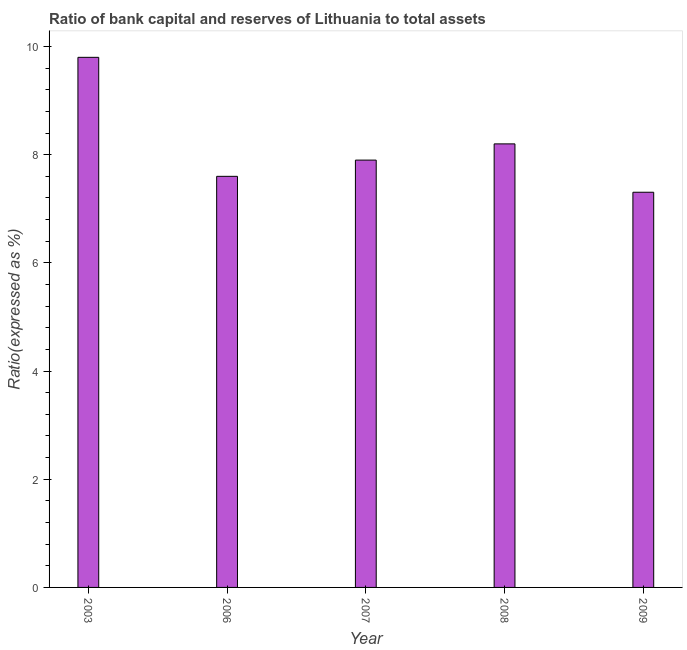What is the title of the graph?
Your answer should be compact. Ratio of bank capital and reserves of Lithuania to total assets. What is the label or title of the X-axis?
Your response must be concise. Year. What is the label or title of the Y-axis?
Your answer should be very brief. Ratio(expressed as %). What is the bank capital to assets ratio in 2008?
Make the answer very short. 8.2. Across all years, what is the maximum bank capital to assets ratio?
Make the answer very short. 9.8. Across all years, what is the minimum bank capital to assets ratio?
Offer a terse response. 7.31. In which year was the bank capital to assets ratio minimum?
Offer a terse response. 2009. What is the sum of the bank capital to assets ratio?
Give a very brief answer. 40.81. What is the average bank capital to assets ratio per year?
Your answer should be compact. 8.16. What is the median bank capital to assets ratio?
Your response must be concise. 7.9. In how many years, is the bank capital to assets ratio greater than 8.8 %?
Ensure brevity in your answer.  1. What is the ratio of the bank capital to assets ratio in 2003 to that in 2008?
Provide a succinct answer. 1.2. Is the bank capital to assets ratio in 2007 less than that in 2008?
Ensure brevity in your answer.  Yes. Is the difference between the bank capital to assets ratio in 2007 and 2008 greater than the difference between any two years?
Keep it short and to the point. No. What is the difference between the highest and the lowest bank capital to assets ratio?
Your answer should be very brief. 2.49. How many bars are there?
Provide a short and direct response. 5. Are all the bars in the graph horizontal?
Offer a very short reply. No. Are the values on the major ticks of Y-axis written in scientific E-notation?
Provide a succinct answer. No. What is the Ratio(expressed as %) of 2009?
Make the answer very short. 7.31. What is the difference between the Ratio(expressed as %) in 2003 and 2006?
Your answer should be very brief. 2.2. What is the difference between the Ratio(expressed as %) in 2003 and 2009?
Keep it short and to the point. 2.49. What is the difference between the Ratio(expressed as %) in 2006 and 2007?
Ensure brevity in your answer.  -0.3. What is the difference between the Ratio(expressed as %) in 2006 and 2009?
Make the answer very short. 0.29. What is the difference between the Ratio(expressed as %) in 2007 and 2008?
Give a very brief answer. -0.3. What is the difference between the Ratio(expressed as %) in 2007 and 2009?
Make the answer very short. 0.59. What is the difference between the Ratio(expressed as %) in 2008 and 2009?
Ensure brevity in your answer.  0.89. What is the ratio of the Ratio(expressed as %) in 2003 to that in 2006?
Your answer should be compact. 1.29. What is the ratio of the Ratio(expressed as %) in 2003 to that in 2007?
Give a very brief answer. 1.24. What is the ratio of the Ratio(expressed as %) in 2003 to that in 2008?
Make the answer very short. 1.2. What is the ratio of the Ratio(expressed as %) in 2003 to that in 2009?
Give a very brief answer. 1.34. What is the ratio of the Ratio(expressed as %) in 2006 to that in 2008?
Your answer should be very brief. 0.93. What is the ratio of the Ratio(expressed as %) in 2006 to that in 2009?
Make the answer very short. 1.04. What is the ratio of the Ratio(expressed as %) in 2007 to that in 2009?
Your answer should be very brief. 1.08. What is the ratio of the Ratio(expressed as %) in 2008 to that in 2009?
Provide a short and direct response. 1.12. 